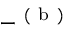Convert formula to latex. <formula><loc_0><loc_0><loc_500><loc_500>- ^ { ( b ) }</formula> 